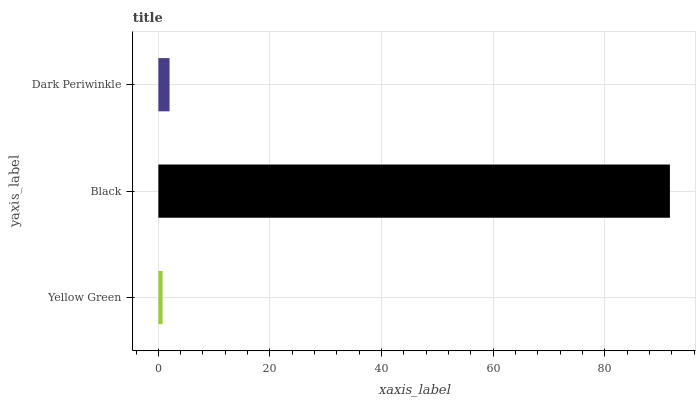Is Yellow Green the minimum?
Answer yes or no. Yes. Is Black the maximum?
Answer yes or no. Yes. Is Dark Periwinkle the minimum?
Answer yes or no. No. Is Dark Periwinkle the maximum?
Answer yes or no. No. Is Black greater than Dark Periwinkle?
Answer yes or no. Yes. Is Dark Periwinkle less than Black?
Answer yes or no. Yes. Is Dark Periwinkle greater than Black?
Answer yes or no. No. Is Black less than Dark Periwinkle?
Answer yes or no. No. Is Dark Periwinkle the high median?
Answer yes or no. Yes. Is Dark Periwinkle the low median?
Answer yes or no. Yes. Is Yellow Green the high median?
Answer yes or no. No. Is Yellow Green the low median?
Answer yes or no. No. 